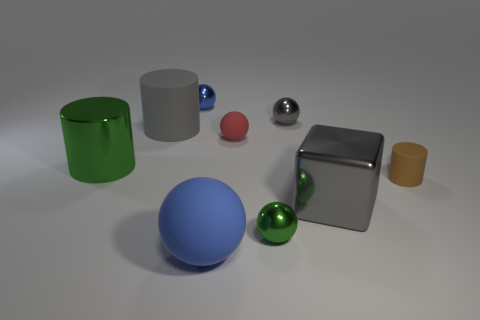Subtract all blue balls. How many balls are left? 3 Subtract 3 spheres. How many spheres are left? 2 Subtract all green balls. How many balls are left? 4 Subtract all yellow spheres. Subtract all brown cubes. How many spheres are left? 5 Add 1 matte spheres. How many objects exist? 10 Subtract all cylinders. How many objects are left? 6 Add 5 big purple spheres. How many big purple spheres exist? 5 Subtract 0 brown spheres. How many objects are left? 9 Subtract all blue matte objects. Subtract all green objects. How many objects are left? 6 Add 6 blue rubber things. How many blue rubber things are left? 7 